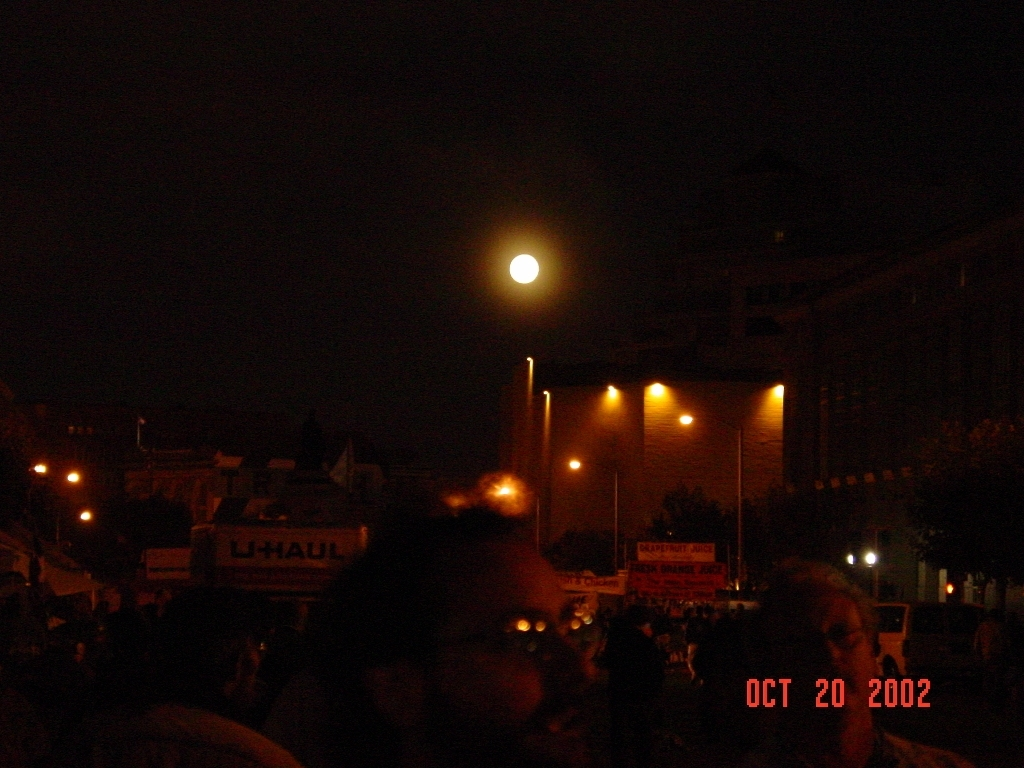Is there a loss of street details in the image? Yes, there appears to be a significant loss of street details in the image, likely due to the low-light conditions and overexposure from the bright lights that lead to limited visibility of the surroundings and make it challenging to discern specific features. 